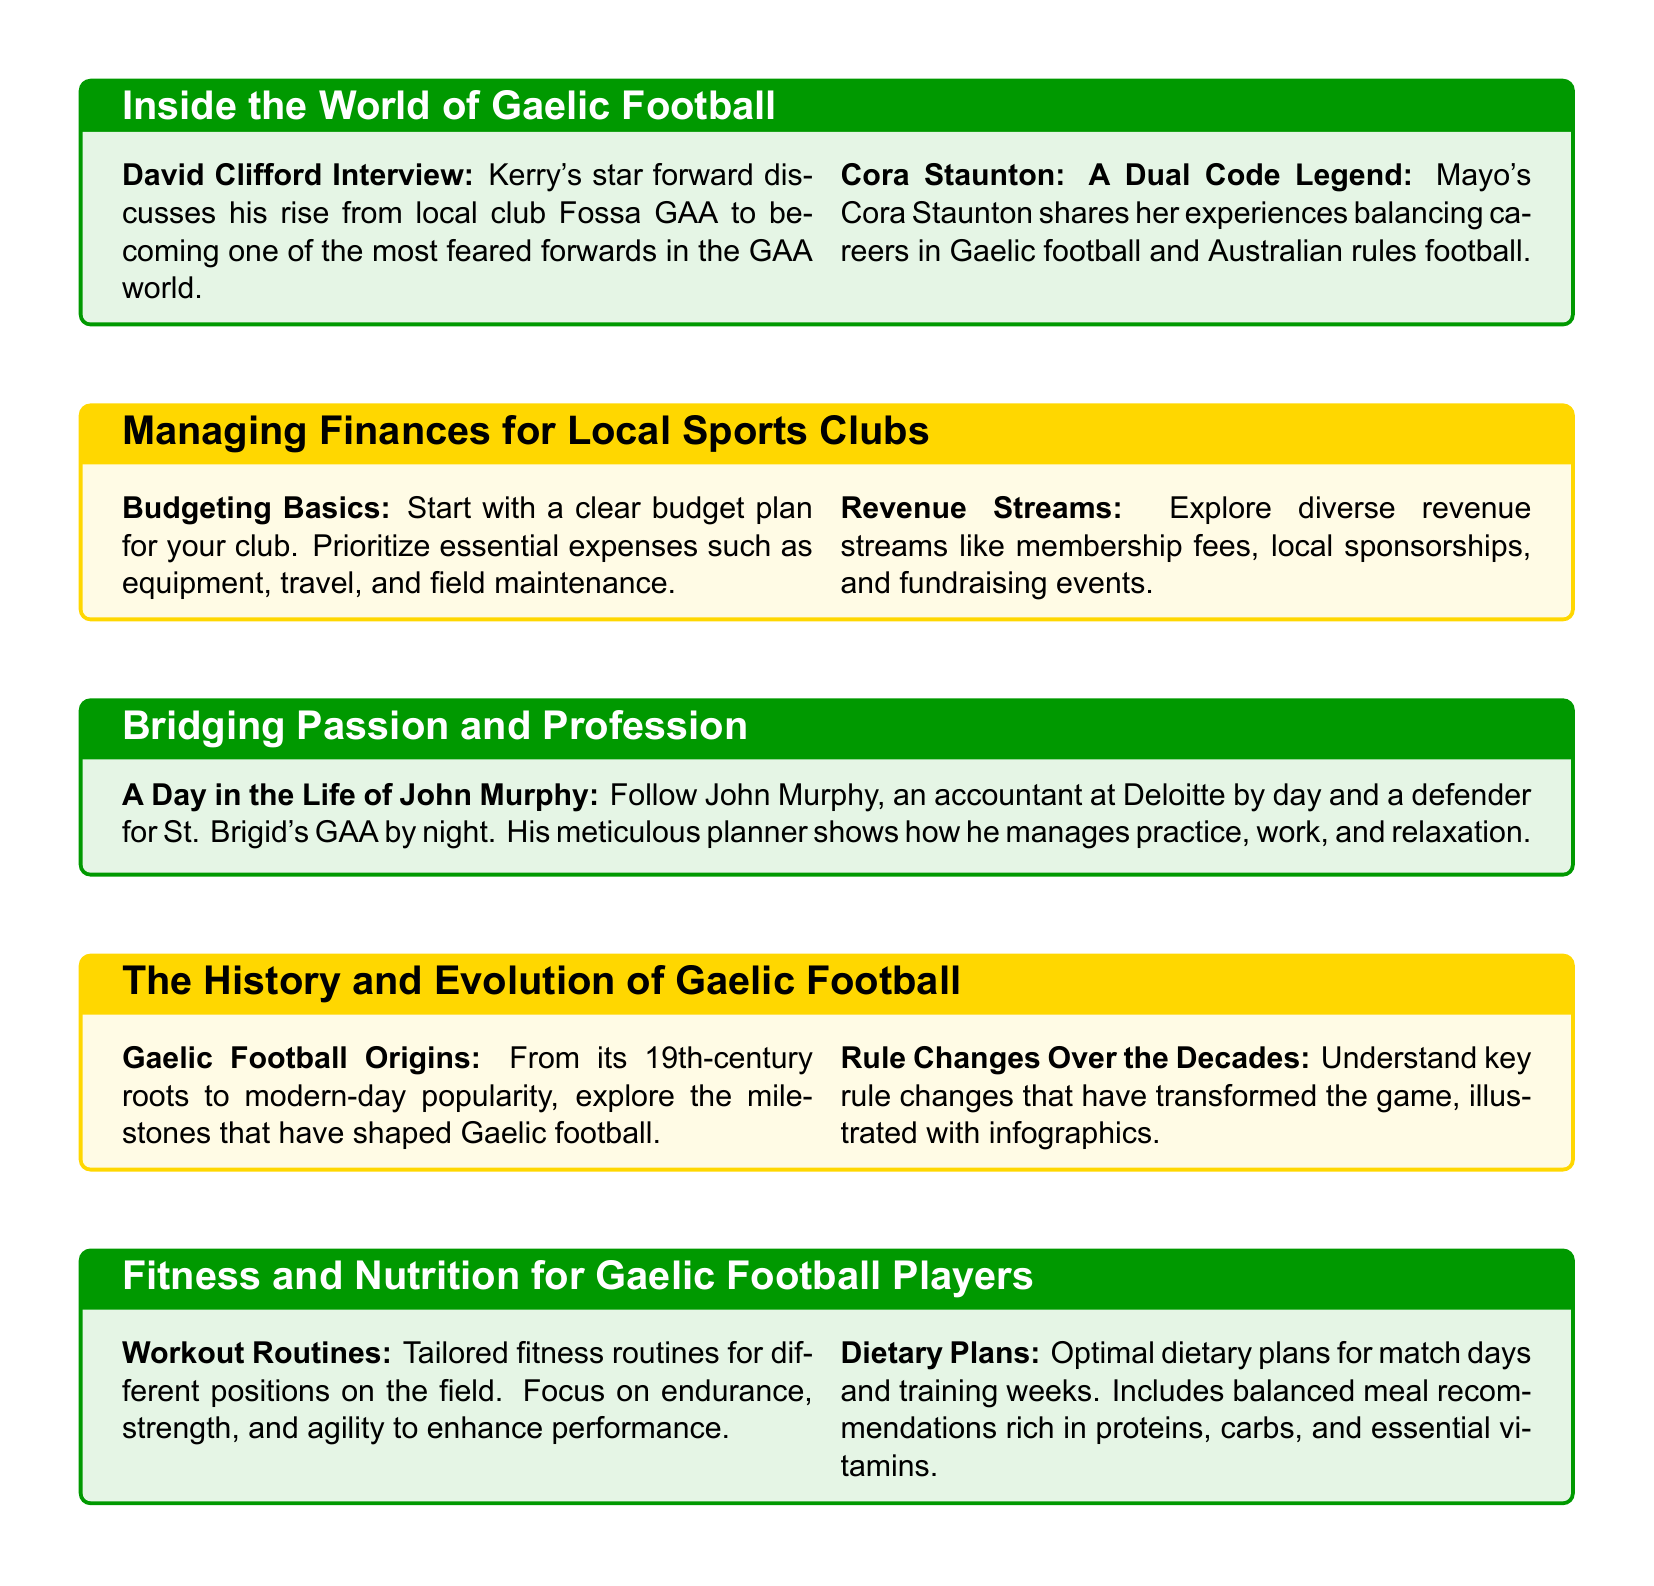What is the interview featured in "Inside the World of Gaelic Football"? The document highlights interviews with David Clifford, discussing his rise in Gaelic football, and Cora Staunton, sharing her experiences in both Gaelic and Australian football.
Answer: David Clifford, Cora Staunton What are essential expenses listed in "Managing Finances for Local Sports Clubs"? The document emphasizes prioritizing expenses such as equipment, travel, and field maintenance as essential.
Answer: Equipment, travel, field maintenance Who is the accountant featured in "Bridging Passion and Profession"? The lifestyle feature centers around John Murphy, who balances being an accountant and a footballer.
Answer: John Murphy What historic aspect is covered in "The History and Evolution of Gaelic Football"? The document discusses the origins of Gaelic football and key milestones that have shaped the game over the years.
Answer: Origins, key milestones What type of dietary plans are recommended in "Fitness and Nutrition for Gaelic Football Players"? The dietary plans outlined in the document are optimal for match days and training weeks, focusing on balanced meals.
Answer: Match days, training weeks What major theme runs through the "Inside the World of Gaelic Football" section? The major theme centers around top GAA stars and their journeys from local leagues to elite status in Gaelic football.
Answer: Journeys from local leagues to elite status What visual elements are present to enhance understanding in "The History and Evolution of Gaelic Football"? The document utilizes vintage photos and infographics to illustrate the evolution of Gaelic football.
Answer: Vintage photos, infographics How are workout routines categorized in "Fitness and Nutrition for Gaelic Football Players"? The workout routines are tailored specifically for different positions on the field, focusing on aspects like endurance, strength, and agility.
Answer: Different positions on the field 